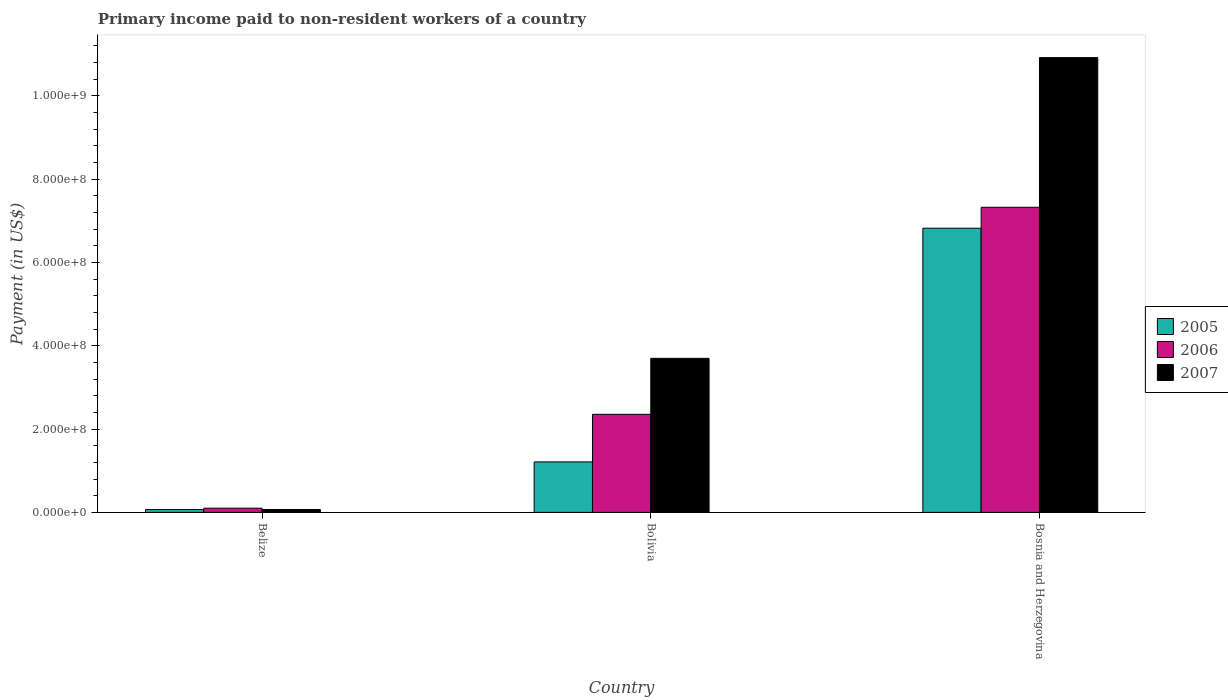How many different coloured bars are there?
Make the answer very short. 3. Are the number of bars per tick equal to the number of legend labels?
Give a very brief answer. Yes. How many bars are there on the 3rd tick from the right?
Give a very brief answer. 3. What is the label of the 1st group of bars from the left?
Give a very brief answer. Belize. What is the amount paid to workers in 2007 in Belize?
Your response must be concise. 6.97e+06. Across all countries, what is the maximum amount paid to workers in 2005?
Offer a very short reply. 6.82e+08. Across all countries, what is the minimum amount paid to workers in 2006?
Ensure brevity in your answer.  1.01e+07. In which country was the amount paid to workers in 2005 maximum?
Ensure brevity in your answer.  Bosnia and Herzegovina. In which country was the amount paid to workers in 2005 minimum?
Your answer should be very brief. Belize. What is the total amount paid to workers in 2005 in the graph?
Keep it short and to the point. 8.10e+08. What is the difference between the amount paid to workers in 2006 in Bolivia and that in Bosnia and Herzegovina?
Offer a very short reply. -4.97e+08. What is the difference between the amount paid to workers in 2006 in Belize and the amount paid to workers in 2007 in Bosnia and Herzegovina?
Offer a terse response. -1.08e+09. What is the average amount paid to workers in 2005 per country?
Provide a short and direct response. 2.70e+08. What is the difference between the amount paid to workers of/in 2007 and amount paid to workers of/in 2006 in Bolivia?
Your response must be concise. 1.34e+08. What is the ratio of the amount paid to workers in 2007 in Belize to that in Bolivia?
Make the answer very short. 0.02. What is the difference between the highest and the second highest amount paid to workers in 2005?
Your answer should be compact. 1.14e+08. What is the difference between the highest and the lowest amount paid to workers in 2007?
Provide a succinct answer. 1.08e+09. Is it the case that in every country, the sum of the amount paid to workers in 2007 and amount paid to workers in 2005 is greater than the amount paid to workers in 2006?
Your response must be concise. Yes. Are all the bars in the graph horizontal?
Ensure brevity in your answer.  No. How many countries are there in the graph?
Your answer should be very brief. 3. Does the graph contain grids?
Offer a very short reply. No. Where does the legend appear in the graph?
Give a very brief answer. Center right. How are the legend labels stacked?
Your answer should be very brief. Vertical. What is the title of the graph?
Your answer should be very brief. Primary income paid to non-resident workers of a country. Does "1999" appear as one of the legend labels in the graph?
Give a very brief answer. No. What is the label or title of the X-axis?
Your answer should be compact. Country. What is the label or title of the Y-axis?
Your answer should be very brief. Payment (in US$). What is the Payment (in US$) of 2005 in Belize?
Offer a terse response. 6.78e+06. What is the Payment (in US$) in 2006 in Belize?
Ensure brevity in your answer.  1.01e+07. What is the Payment (in US$) of 2007 in Belize?
Your answer should be compact. 6.97e+06. What is the Payment (in US$) in 2005 in Bolivia?
Provide a short and direct response. 1.21e+08. What is the Payment (in US$) of 2006 in Bolivia?
Your answer should be very brief. 2.35e+08. What is the Payment (in US$) in 2007 in Bolivia?
Your response must be concise. 3.70e+08. What is the Payment (in US$) in 2005 in Bosnia and Herzegovina?
Ensure brevity in your answer.  6.82e+08. What is the Payment (in US$) in 2006 in Bosnia and Herzegovina?
Your answer should be compact. 7.33e+08. What is the Payment (in US$) of 2007 in Bosnia and Herzegovina?
Your response must be concise. 1.09e+09. Across all countries, what is the maximum Payment (in US$) in 2005?
Make the answer very short. 6.82e+08. Across all countries, what is the maximum Payment (in US$) of 2006?
Keep it short and to the point. 7.33e+08. Across all countries, what is the maximum Payment (in US$) of 2007?
Make the answer very short. 1.09e+09. Across all countries, what is the minimum Payment (in US$) in 2005?
Your response must be concise. 6.78e+06. Across all countries, what is the minimum Payment (in US$) in 2006?
Provide a succinct answer. 1.01e+07. Across all countries, what is the minimum Payment (in US$) of 2007?
Your answer should be very brief. 6.97e+06. What is the total Payment (in US$) of 2005 in the graph?
Your answer should be compact. 8.10e+08. What is the total Payment (in US$) in 2006 in the graph?
Your response must be concise. 9.78e+08. What is the total Payment (in US$) of 2007 in the graph?
Your answer should be compact. 1.47e+09. What is the difference between the Payment (in US$) in 2005 in Belize and that in Bolivia?
Offer a very short reply. -1.14e+08. What is the difference between the Payment (in US$) of 2006 in Belize and that in Bolivia?
Your response must be concise. -2.25e+08. What is the difference between the Payment (in US$) in 2007 in Belize and that in Bolivia?
Offer a very short reply. -3.63e+08. What is the difference between the Payment (in US$) of 2005 in Belize and that in Bosnia and Herzegovina?
Provide a succinct answer. -6.76e+08. What is the difference between the Payment (in US$) of 2006 in Belize and that in Bosnia and Herzegovina?
Your answer should be very brief. -7.22e+08. What is the difference between the Payment (in US$) of 2007 in Belize and that in Bosnia and Herzegovina?
Provide a succinct answer. -1.08e+09. What is the difference between the Payment (in US$) in 2005 in Bolivia and that in Bosnia and Herzegovina?
Your answer should be compact. -5.61e+08. What is the difference between the Payment (in US$) of 2006 in Bolivia and that in Bosnia and Herzegovina?
Your answer should be very brief. -4.97e+08. What is the difference between the Payment (in US$) of 2007 in Bolivia and that in Bosnia and Herzegovina?
Provide a succinct answer. -7.22e+08. What is the difference between the Payment (in US$) in 2005 in Belize and the Payment (in US$) in 2006 in Bolivia?
Your answer should be very brief. -2.29e+08. What is the difference between the Payment (in US$) of 2005 in Belize and the Payment (in US$) of 2007 in Bolivia?
Your answer should be very brief. -3.63e+08. What is the difference between the Payment (in US$) in 2006 in Belize and the Payment (in US$) in 2007 in Bolivia?
Keep it short and to the point. -3.60e+08. What is the difference between the Payment (in US$) in 2005 in Belize and the Payment (in US$) in 2006 in Bosnia and Herzegovina?
Provide a short and direct response. -7.26e+08. What is the difference between the Payment (in US$) in 2005 in Belize and the Payment (in US$) in 2007 in Bosnia and Herzegovina?
Provide a succinct answer. -1.09e+09. What is the difference between the Payment (in US$) in 2006 in Belize and the Payment (in US$) in 2007 in Bosnia and Herzegovina?
Your answer should be very brief. -1.08e+09. What is the difference between the Payment (in US$) in 2005 in Bolivia and the Payment (in US$) in 2006 in Bosnia and Herzegovina?
Your answer should be very brief. -6.11e+08. What is the difference between the Payment (in US$) in 2005 in Bolivia and the Payment (in US$) in 2007 in Bosnia and Herzegovina?
Make the answer very short. -9.71e+08. What is the difference between the Payment (in US$) in 2006 in Bolivia and the Payment (in US$) in 2007 in Bosnia and Herzegovina?
Your answer should be compact. -8.56e+08. What is the average Payment (in US$) of 2005 per country?
Ensure brevity in your answer.  2.70e+08. What is the average Payment (in US$) in 2006 per country?
Offer a very short reply. 3.26e+08. What is the average Payment (in US$) in 2007 per country?
Provide a succinct answer. 4.90e+08. What is the difference between the Payment (in US$) of 2005 and Payment (in US$) of 2006 in Belize?
Provide a succinct answer. -3.32e+06. What is the difference between the Payment (in US$) of 2005 and Payment (in US$) of 2007 in Belize?
Offer a terse response. -1.86e+05. What is the difference between the Payment (in US$) of 2006 and Payment (in US$) of 2007 in Belize?
Provide a succinct answer. 3.13e+06. What is the difference between the Payment (in US$) of 2005 and Payment (in US$) of 2006 in Bolivia?
Your response must be concise. -1.14e+08. What is the difference between the Payment (in US$) of 2005 and Payment (in US$) of 2007 in Bolivia?
Provide a short and direct response. -2.49e+08. What is the difference between the Payment (in US$) of 2006 and Payment (in US$) of 2007 in Bolivia?
Keep it short and to the point. -1.34e+08. What is the difference between the Payment (in US$) of 2005 and Payment (in US$) of 2006 in Bosnia and Herzegovina?
Give a very brief answer. -5.03e+07. What is the difference between the Payment (in US$) of 2005 and Payment (in US$) of 2007 in Bosnia and Herzegovina?
Offer a very short reply. -4.10e+08. What is the difference between the Payment (in US$) in 2006 and Payment (in US$) in 2007 in Bosnia and Herzegovina?
Your answer should be compact. -3.59e+08. What is the ratio of the Payment (in US$) in 2005 in Belize to that in Bolivia?
Your answer should be very brief. 0.06. What is the ratio of the Payment (in US$) of 2006 in Belize to that in Bolivia?
Your answer should be very brief. 0.04. What is the ratio of the Payment (in US$) of 2007 in Belize to that in Bolivia?
Make the answer very short. 0.02. What is the ratio of the Payment (in US$) in 2005 in Belize to that in Bosnia and Herzegovina?
Provide a short and direct response. 0.01. What is the ratio of the Payment (in US$) in 2006 in Belize to that in Bosnia and Herzegovina?
Your answer should be compact. 0.01. What is the ratio of the Payment (in US$) of 2007 in Belize to that in Bosnia and Herzegovina?
Give a very brief answer. 0.01. What is the ratio of the Payment (in US$) in 2005 in Bolivia to that in Bosnia and Herzegovina?
Your answer should be compact. 0.18. What is the ratio of the Payment (in US$) of 2006 in Bolivia to that in Bosnia and Herzegovina?
Your answer should be very brief. 0.32. What is the ratio of the Payment (in US$) of 2007 in Bolivia to that in Bosnia and Herzegovina?
Give a very brief answer. 0.34. What is the difference between the highest and the second highest Payment (in US$) of 2005?
Provide a short and direct response. 5.61e+08. What is the difference between the highest and the second highest Payment (in US$) in 2006?
Provide a short and direct response. 4.97e+08. What is the difference between the highest and the second highest Payment (in US$) of 2007?
Make the answer very short. 7.22e+08. What is the difference between the highest and the lowest Payment (in US$) in 2005?
Provide a succinct answer. 6.76e+08. What is the difference between the highest and the lowest Payment (in US$) of 2006?
Provide a short and direct response. 7.22e+08. What is the difference between the highest and the lowest Payment (in US$) in 2007?
Your answer should be compact. 1.08e+09. 